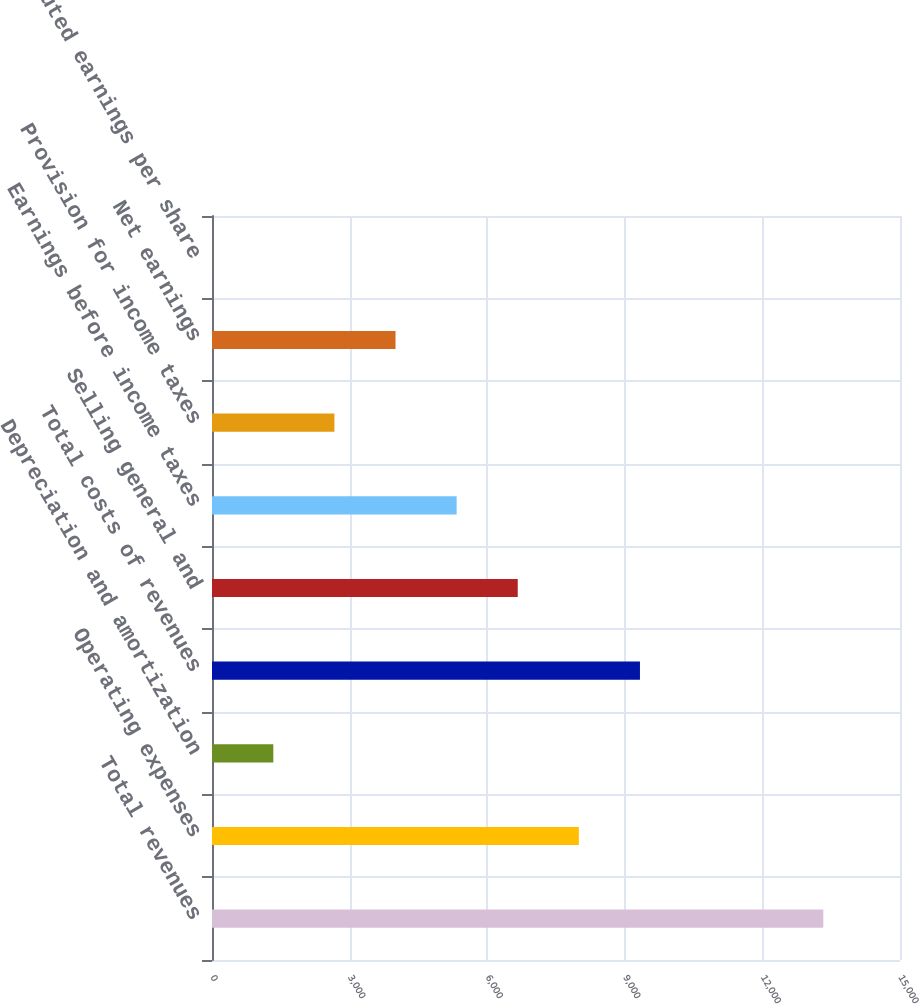Convert chart. <chart><loc_0><loc_0><loc_500><loc_500><bar_chart><fcel>Total revenues<fcel>Operating expenses<fcel>Depreciation and amortization<fcel>Total costs of revenues<fcel>Selling general and<fcel>Earnings before income taxes<fcel>Provision for income taxes<fcel>Net earnings<fcel>Diluted earnings per share<nl><fcel>13327.7<fcel>7998.34<fcel>1336.6<fcel>9330.69<fcel>6665.99<fcel>5333.65<fcel>2668.95<fcel>4001.3<fcel>4.25<nl></chart> 